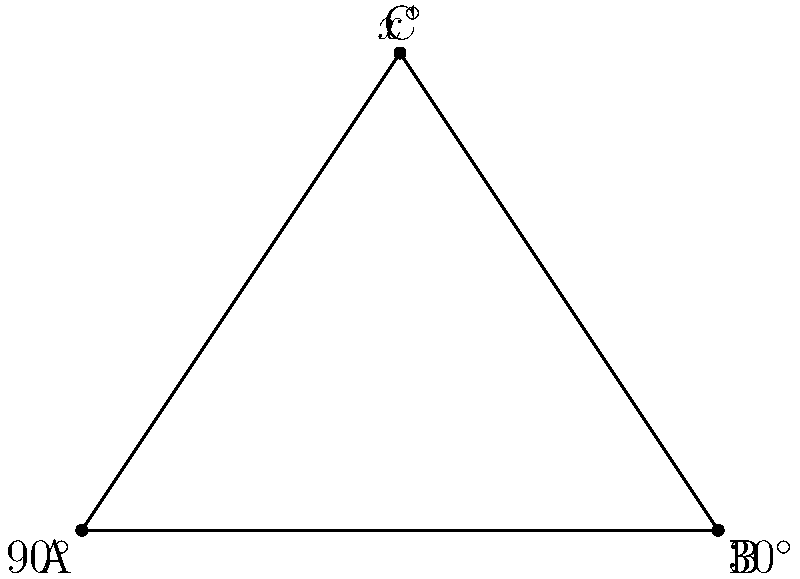In your convenience store, two aisles intersect at point C, forming a triangle with the back wall (AB). If the angle between the back wall and one aisle is $90^\circ$ at point A, and the angle between the back wall and the other aisle is $30^\circ$ at point B, what is the angle $x^\circ$ where the aisles intersect at point C? To solve this problem, we'll use the properties of triangles:

1. In any triangle, the sum of all interior angles is always $180^\circ$.

2. We know two angles of the triangle:
   - Angle at A = $90^\circ$
   - Angle at B = $30^\circ$

3. Let's call the unknown angle at C as $x^\circ$.

4. We can set up an equation based on the fact that the sum of all angles in a triangle is $180^\circ$:
   
   $90^\circ + 30^\circ + x^\circ = 180^\circ$

5. Simplify:
   
   $120^\circ + x^\circ = 180^\circ$

6. Subtract $120^\circ$ from both sides:
   
   $x^\circ = 180^\circ - 120^\circ = 60^\circ$

Therefore, the angle where the two aisles intersect at point C is $60^\circ$.
Answer: $60^\circ$ 